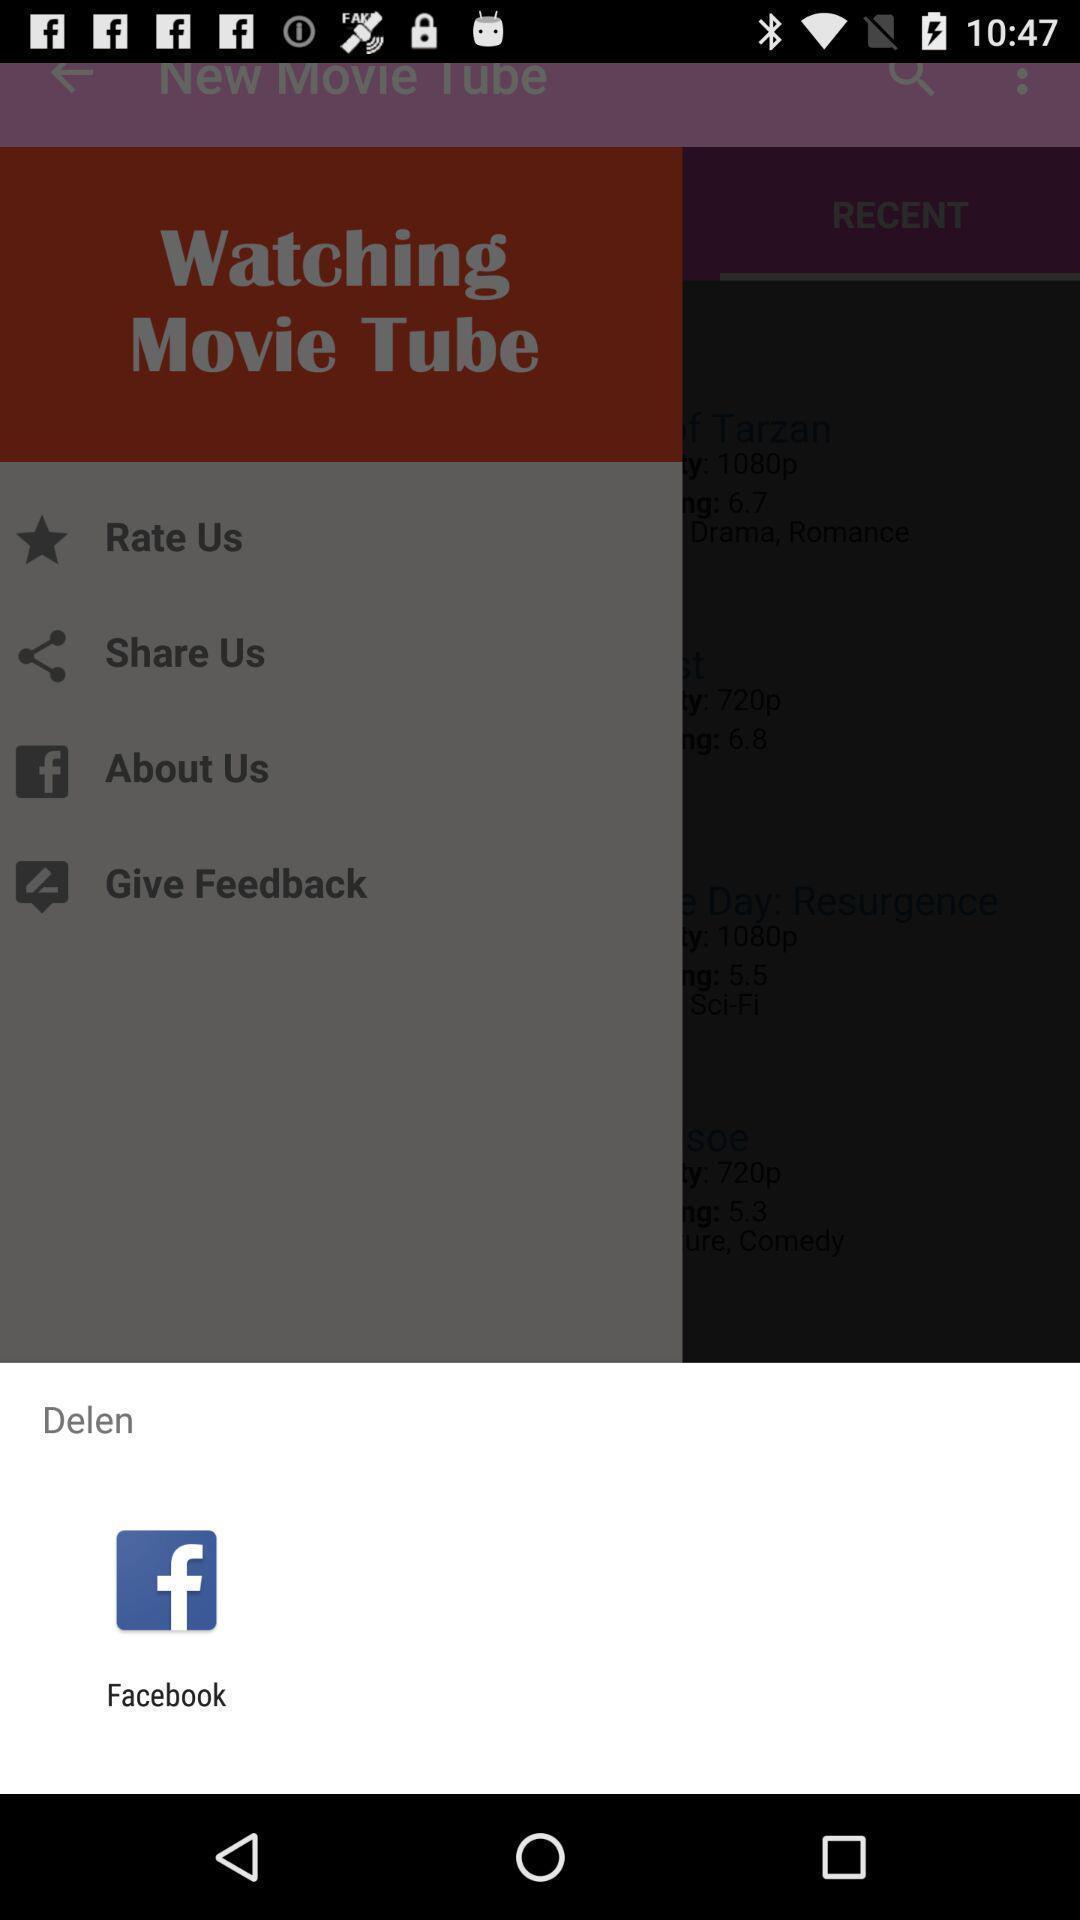Describe the key features of this screenshot. Pop-up showing the social app. 